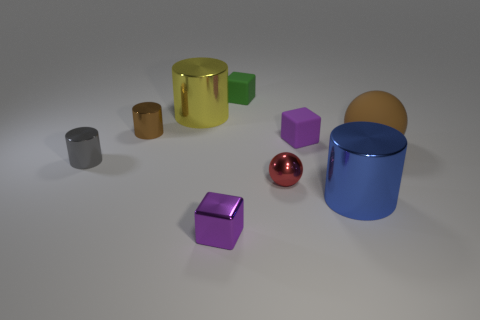There is a rubber block that is in front of the small green thing; is it the same color as the small metal block?
Offer a very short reply. Yes. Are there any other things that are the same shape as the blue shiny thing?
Keep it short and to the point. Yes. The tiny thing that is the same shape as the large brown thing is what color?
Your answer should be very brief. Red. There is a purple object behind the large brown object; what is its material?
Your response must be concise. Rubber. The large ball is what color?
Give a very brief answer. Brown. Do the block in front of the gray shiny object and the small gray cylinder have the same size?
Offer a terse response. Yes. What is the material of the tiny purple cube that is to the right of the small matte block that is behind the brown cylinder that is behind the small gray object?
Give a very brief answer. Rubber. There is a small thing in front of the tiny red object; does it have the same color as the rubber cube that is in front of the small green block?
Give a very brief answer. Yes. The tiny purple block that is on the right side of the tiny purple cube that is in front of the small gray metallic thing is made of what material?
Your response must be concise. Rubber. There is a cylinder that is the same size as the gray thing; what color is it?
Your answer should be compact. Brown. 